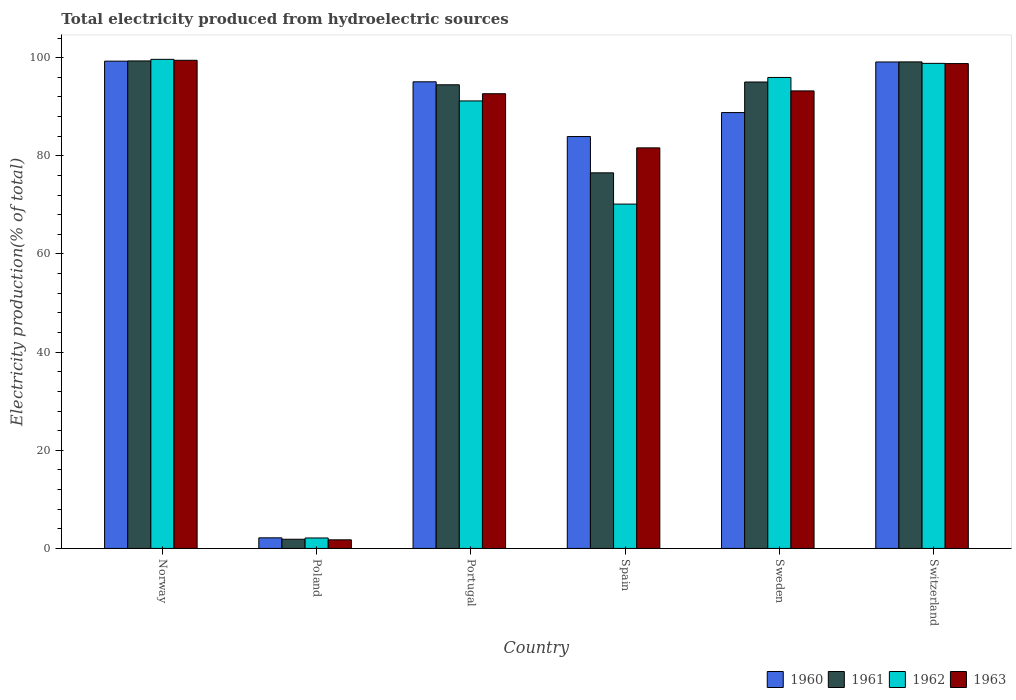How many bars are there on the 4th tick from the left?
Provide a short and direct response. 4. How many bars are there on the 2nd tick from the right?
Make the answer very short. 4. What is the total electricity produced in 1961 in Norway?
Make the answer very short. 99.34. Across all countries, what is the maximum total electricity produced in 1962?
Offer a very short reply. 99.67. Across all countries, what is the minimum total electricity produced in 1962?
Provide a short and direct response. 2.13. What is the total total electricity produced in 1960 in the graph?
Your response must be concise. 468.44. What is the difference between the total electricity produced in 1962 in Norway and that in Poland?
Provide a short and direct response. 97.54. What is the difference between the total electricity produced in 1961 in Sweden and the total electricity produced in 1962 in Poland?
Offer a very short reply. 92.92. What is the average total electricity produced in 1961 per country?
Your answer should be very brief. 77.74. What is the difference between the total electricity produced of/in 1963 and total electricity produced of/in 1962 in Poland?
Keep it short and to the point. -0.38. What is the ratio of the total electricity produced in 1963 in Poland to that in Sweden?
Make the answer very short. 0.02. What is the difference between the highest and the second highest total electricity produced in 1960?
Your answer should be compact. -0.17. What is the difference between the highest and the lowest total electricity produced in 1960?
Your answer should be very brief. 97.14. In how many countries, is the total electricity produced in 1961 greater than the average total electricity produced in 1961 taken over all countries?
Provide a short and direct response. 4. Is the sum of the total electricity produced in 1961 in Norway and Spain greater than the maximum total electricity produced in 1960 across all countries?
Provide a short and direct response. Yes. What does the 1st bar from the right in Portugal represents?
Make the answer very short. 1963. Is it the case that in every country, the sum of the total electricity produced in 1961 and total electricity produced in 1963 is greater than the total electricity produced in 1960?
Your answer should be very brief. Yes. How many bars are there?
Make the answer very short. 24. Are all the bars in the graph horizontal?
Your response must be concise. No. Does the graph contain grids?
Offer a terse response. No. What is the title of the graph?
Keep it short and to the point. Total electricity produced from hydroelectric sources. What is the label or title of the X-axis?
Keep it short and to the point. Country. What is the label or title of the Y-axis?
Your response must be concise. Electricity production(% of total). What is the Electricity production(% of total) of 1960 in Norway?
Ensure brevity in your answer.  99.3. What is the Electricity production(% of total) in 1961 in Norway?
Provide a succinct answer. 99.34. What is the Electricity production(% of total) of 1962 in Norway?
Provide a succinct answer. 99.67. What is the Electricity production(% of total) in 1963 in Norway?
Keep it short and to the point. 99.47. What is the Electricity production(% of total) in 1960 in Poland?
Offer a very short reply. 2.16. What is the Electricity production(% of total) of 1961 in Poland?
Your response must be concise. 1.87. What is the Electricity production(% of total) of 1962 in Poland?
Give a very brief answer. 2.13. What is the Electricity production(% of total) in 1963 in Poland?
Ensure brevity in your answer.  1.75. What is the Electricity production(% of total) in 1960 in Portugal?
Your answer should be compact. 95.09. What is the Electricity production(% of total) of 1961 in Portugal?
Offer a very short reply. 94.48. What is the Electricity production(% of total) in 1962 in Portugal?
Your answer should be very brief. 91.19. What is the Electricity production(% of total) of 1963 in Portugal?
Your answer should be very brief. 92.66. What is the Electricity production(% of total) in 1960 in Spain?
Offer a very short reply. 83.94. What is the Electricity production(% of total) of 1961 in Spain?
Provide a short and direct response. 76.54. What is the Electricity production(% of total) of 1962 in Spain?
Keep it short and to the point. 70.17. What is the Electricity production(% of total) in 1963 in Spain?
Keep it short and to the point. 81.63. What is the Electricity production(% of total) of 1960 in Sweden?
Ensure brevity in your answer.  88.82. What is the Electricity production(% of total) of 1961 in Sweden?
Ensure brevity in your answer.  95.05. What is the Electricity production(% of total) in 1962 in Sweden?
Provide a succinct answer. 95.98. What is the Electricity production(% of total) of 1963 in Sweden?
Offer a very short reply. 93.24. What is the Electricity production(% of total) of 1960 in Switzerland?
Give a very brief answer. 99.13. What is the Electricity production(% of total) of 1961 in Switzerland?
Offer a terse response. 99.15. What is the Electricity production(% of total) in 1962 in Switzerland?
Give a very brief answer. 98.85. What is the Electricity production(% of total) of 1963 in Switzerland?
Offer a very short reply. 98.81. Across all countries, what is the maximum Electricity production(% of total) in 1960?
Make the answer very short. 99.3. Across all countries, what is the maximum Electricity production(% of total) of 1961?
Offer a very short reply. 99.34. Across all countries, what is the maximum Electricity production(% of total) of 1962?
Provide a succinct answer. 99.67. Across all countries, what is the maximum Electricity production(% of total) of 1963?
Give a very brief answer. 99.47. Across all countries, what is the minimum Electricity production(% of total) of 1960?
Provide a succinct answer. 2.16. Across all countries, what is the minimum Electricity production(% of total) of 1961?
Your answer should be very brief. 1.87. Across all countries, what is the minimum Electricity production(% of total) in 1962?
Your answer should be compact. 2.13. Across all countries, what is the minimum Electricity production(% of total) in 1963?
Ensure brevity in your answer.  1.75. What is the total Electricity production(% of total) of 1960 in the graph?
Your answer should be compact. 468.44. What is the total Electricity production(% of total) of 1961 in the graph?
Make the answer very short. 466.43. What is the total Electricity production(% of total) of 1962 in the graph?
Keep it short and to the point. 457.99. What is the total Electricity production(% of total) of 1963 in the graph?
Offer a terse response. 467.56. What is the difference between the Electricity production(% of total) of 1960 in Norway and that in Poland?
Your answer should be very brief. 97.14. What is the difference between the Electricity production(% of total) of 1961 in Norway and that in Poland?
Make the answer very short. 97.47. What is the difference between the Electricity production(% of total) of 1962 in Norway and that in Poland?
Offer a very short reply. 97.54. What is the difference between the Electricity production(% of total) in 1963 in Norway and that in Poland?
Make the answer very short. 97.72. What is the difference between the Electricity production(% of total) of 1960 in Norway and that in Portugal?
Your answer should be compact. 4.21. What is the difference between the Electricity production(% of total) of 1961 in Norway and that in Portugal?
Provide a short and direct response. 4.86. What is the difference between the Electricity production(% of total) of 1962 in Norway and that in Portugal?
Your response must be concise. 8.48. What is the difference between the Electricity production(% of total) in 1963 in Norway and that in Portugal?
Offer a terse response. 6.81. What is the difference between the Electricity production(% of total) in 1960 in Norway and that in Spain?
Provide a succinct answer. 15.36. What is the difference between the Electricity production(% of total) of 1961 in Norway and that in Spain?
Provide a succinct answer. 22.8. What is the difference between the Electricity production(% of total) in 1962 in Norway and that in Spain?
Your answer should be compact. 29.5. What is the difference between the Electricity production(% of total) in 1963 in Norway and that in Spain?
Give a very brief answer. 17.85. What is the difference between the Electricity production(% of total) in 1960 in Norway and that in Sweden?
Give a very brief answer. 10.48. What is the difference between the Electricity production(% of total) of 1961 in Norway and that in Sweden?
Your response must be concise. 4.29. What is the difference between the Electricity production(% of total) of 1962 in Norway and that in Sweden?
Provide a short and direct response. 3.69. What is the difference between the Electricity production(% of total) in 1963 in Norway and that in Sweden?
Ensure brevity in your answer.  6.24. What is the difference between the Electricity production(% of total) of 1960 in Norway and that in Switzerland?
Your response must be concise. 0.17. What is the difference between the Electricity production(% of total) in 1961 in Norway and that in Switzerland?
Offer a very short reply. 0.2. What is the difference between the Electricity production(% of total) in 1962 in Norway and that in Switzerland?
Keep it short and to the point. 0.82. What is the difference between the Electricity production(% of total) of 1963 in Norway and that in Switzerland?
Your answer should be compact. 0.67. What is the difference between the Electricity production(% of total) in 1960 in Poland and that in Portugal?
Ensure brevity in your answer.  -92.93. What is the difference between the Electricity production(% of total) of 1961 in Poland and that in Portugal?
Provide a short and direct response. -92.61. What is the difference between the Electricity production(% of total) in 1962 in Poland and that in Portugal?
Provide a succinct answer. -89.06. What is the difference between the Electricity production(% of total) of 1963 in Poland and that in Portugal?
Give a very brief answer. -90.91. What is the difference between the Electricity production(% of total) of 1960 in Poland and that in Spain?
Provide a succinct answer. -81.78. What is the difference between the Electricity production(% of total) of 1961 in Poland and that in Spain?
Offer a very short reply. -74.67. What is the difference between the Electricity production(% of total) in 1962 in Poland and that in Spain?
Your response must be concise. -68.04. What is the difference between the Electricity production(% of total) in 1963 in Poland and that in Spain?
Offer a terse response. -79.88. What is the difference between the Electricity production(% of total) of 1960 in Poland and that in Sweden?
Provide a succinct answer. -86.66. What is the difference between the Electricity production(% of total) of 1961 in Poland and that in Sweden?
Your answer should be compact. -93.17. What is the difference between the Electricity production(% of total) in 1962 in Poland and that in Sweden?
Offer a terse response. -93.84. What is the difference between the Electricity production(% of total) of 1963 in Poland and that in Sweden?
Give a very brief answer. -91.48. What is the difference between the Electricity production(% of total) in 1960 in Poland and that in Switzerland?
Keep it short and to the point. -96.97. What is the difference between the Electricity production(% of total) in 1961 in Poland and that in Switzerland?
Offer a terse response. -97.27. What is the difference between the Electricity production(% of total) of 1962 in Poland and that in Switzerland?
Make the answer very short. -96.71. What is the difference between the Electricity production(% of total) in 1963 in Poland and that in Switzerland?
Provide a short and direct response. -97.06. What is the difference between the Electricity production(% of total) of 1960 in Portugal and that in Spain?
Offer a terse response. 11.15. What is the difference between the Electricity production(% of total) in 1961 in Portugal and that in Spain?
Provide a short and direct response. 17.94. What is the difference between the Electricity production(% of total) of 1962 in Portugal and that in Spain?
Make the answer very short. 21.02. What is the difference between the Electricity production(% of total) in 1963 in Portugal and that in Spain?
Make the answer very short. 11.03. What is the difference between the Electricity production(% of total) of 1960 in Portugal and that in Sweden?
Offer a terse response. 6.27. What is the difference between the Electricity production(% of total) in 1961 in Portugal and that in Sweden?
Offer a terse response. -0.57. What is the difference between the Electricity production(% of total) in 1962 in Portugal and that in Sweden?
Give a very brief answer. -4.78. What is the difference between the Electricity production(% of total) of 1963 in Portugal and that in Sweden?
Keep it short and to the point. -0.58. What is the difference between the Electricity production(% of total) in 1960 in Portugal and that in Switzerland?
Make the answer very short. -4.04. What is the difference between the Electricity production(% of total) in 1961 in Portugal and that in Switzerland?
Offer a very short reply. -4.67. What is the difference between the Electricity production(% of total) in 1962 in Portugal and that in Switzerland?
Ensure brevity in your answer.  -7.65. What is the difference between the Electricity production(% of total) of 1963 in Portugal and that in Switzerland?
Make the answer very short. -6.15. What is the difference between the Electricity production(% of total) in 1960 in Spain and that in Sweden?
Provide a succinct answer. -4.88. What is the difference between the Electricity production(% of total) in 1961 in Spain and that in Sweden?
Offer a terse response. -18.51. What is the difference between the Electricity production(% of total) of 1962 in Spain and that in Sweden?
Ensure brevity in your answer.  -25.8. What is the difference between the Electricity production(% of total) in 1963 in Spain and that in Sweden?
Your response must be concise. -11.61. What is the difference between the Electricity production(% of total) in 1960 in Spain and that in Switzerland?
Offer a very short reply. -15.19. What is the difference between the Electricity production(% of total) of 1961 in Spain and that in Switzerland?
Your answer should be compact. -22.61. What is the difference between the Electricity production(% of total) of 1962 in Spain and that in Switzerland?
Ensure brevity in your answer.  -28.67. What is the difference between the Electricity production(% of total) of 1963 in Spain and that in Switzerland?
Offer a very short reply. -17.18. What is the difference between the Electricity production(% of total) of 1960 in Sweden and that in Switzerland?
Give a very brief answer. -10.31. What is the difference between the Electricity production(% of total) in 1961 in Sweden and that in Switzerland?
Offer a very short reply. -4.1. What is the difference between the Electricity production(% of total) of 1962 in Sweden and that in Switzerland?
Your response must be concise. -2.87. What is the difference between the Electricity production(% of total) of 1963 in Sweden and that in Switzerland?
Your response must be concise. -5.57. What is the difference between the Electricity production(% of total) in 1960 in Norway and the Electricity production(% of total) in 1961 in Poland?
Offer a very short reply. 97.43. What is the difference between the Electricity production(% of total) in 1960 in Norway and the Electricity production(% of total) in 1962 in Poland?
Ensure brevity in your answer.  97.17. What is the difference between the Electricity production(% of total) of 1960 in Norway and the Electricity production(% of total) of 1963 in Poland?
Provide a short and direct response. 97.55. What is the difference between the Electricity production(% of total) in 1961 in Norway and the Electricity production(% of total) in 1962 in Poland?
Your response must be concise. 97.21. What is the difference between the Electricity production(% of total) in 1961 in Norway and the Electricity production(% of total) in 1963 in Poland?
Provide a short and direct response. 97.59. What is the difference between the Electricity production(% of total) of 1962 in Norway and the Electricity production(% of total) of 1963 in Poland?
Provide a short and direct response. 97.92. What is the difference between the Electricity production(% of total) of 1960 in Norway and the Electricity production(% of total) of 1961 in Portugal?
Provide a succinct answer. 4.82. What is the difference between the Electricity production(% of total) in 1960 in Norway and the Electricity production(% of total) in 1962 in Portugal?
Offer a terse response. 8.11. What is the difference between the Electricity production(% of total) of 1960 in Norway and the Electricity production(% of total) of 1963 in Portugal?
Give a very brief answer. 6.64. What is the difference between the Electricity production(% of total) of 1961 in Norway and the Electricity production(% of total) of 1962 in Portugal?
Offer a very short reply. 8.15. What is the difference between the Electricity production(% of total) of 1961 in Norway and the Electricity production(% of total) of 1963 in Portugal?
Ensure brevity in your answer.  6.68. What is the difference between the Electricity production(% of total) in 1962 in Norway and the Electricity production(% of total) in 1963 in Portugal?
Your answer should be compact. 7.01. What is the difference between the Electricity production(% of total) in 1960 in Norway and the Electricity production(% of total) in 1961 in Spain?
Ensure brevity in your answer.  22.76. What is the difference between the Electricity production(% of total) of 1960 in Norway and the Electricity production(% of total) of 1962 in Spain?
Keep it short and to the point. 29.13. What is the difference between the Electricity production(% of total) of 1960 in Norway and the Electricity production(% of total) of 1963 in Spain?
Offer a terse response. 17.67. What is the difference between the Electricity production(% of total) of 1961 in Norway and the Electricity production(% of total) of 1962 in Spain?
Make the answer very short. 29.17. What is the difference between the Electricity production(% of total) of 1961 in Norway and the Electricity production(% of total) of 1963 in Spain?
Give a very brief answer. 17.72. What is the difference between the Electricity production(% of total) of 1962 in Norway and the Electricity production(% of total) of 1963 in Spain?
Ensure brevity in your answer.  18.04. What is the difference between the Electricity production(% of total) of 1960 in Norway and the Electricity production(% of total) of 1961 in Sweden?
Your answer should be very brief. 4.25. What is the difference between the Electricity production(% of total) in 1960 in Norway and the Electricity production(% of total) in 1962 in Sweden?
Provide a succinct answer. 3.33. What is the difference between the Electricity production(% of total) in 1960 in Norway and the Electricity production(% of total) in 1963 in Sweden?
Your response must be concise. 6.06. What is the difference between the Electricity production(% of total) of 1961 in Norway and the Electricity production(% of total) of 1962 in Sweden?
Keep it short and to the point. 3.37. What is the difference between the Electricity production(% of total) in 1961 in Norway and the Electricity production(% of total) in 1963 in Sweden?
Provide a succinct answer. 6.11. What is the difference between the Electricity production(% of total) of 1962 in Norway and the Electricity production(% of total) of 1963 in Sweden?
Your response must be concise. 6.43. What is the difference between the Electricity production(% of total) of 1960 in Norway and the Electricity production(% of total) of 1961 in Switzerland?
Make the answer very short. 0.15. What is the difference between the Electricity production(% of total) of 1960 in Norway and the Electricity production(% of total) of 1962 in Switzerland?
Your answer should be very brief. 0.45. What is the difference between the Electricity production(% of total) in 1960 in Norway and the Electricity production(% of total) in 1963 in Switzerland?
Keep it short and to the point. 0.49. What is the difference between the Electricity production(% of total) in 1961 in Norway and the Electricity production(% of total) in 1962 in Switzerland?
Make the answer very short. 0.5. What is the difference between the Electricity production(% of total) of 1961 in Norway and the Electricity production(% of total) of 1963 in Switzerland?
Ensure brevity in your answer.  0.54. What is the difference between the Electricity production(% of total) in 1962 in Norway and the Electricity production(% of total) in 1963 in Switzerland?
Give a very brief answer. 0.86. What is the difference between the Electricity production(% of total) of 1960 in Poland and the Electricity production(% of total) of 1961 in Portugal?
Your answer should be compact. -92.32. What is the difference between the Electricity production(% of total) in 1960 in Poland and the Electricity production(% of total) in 1962 in Portugal?
Your answer should be very brief. -89.03. What is the difference between the Electricity production(% of total) of 1960 in Poland and the Electricity production(% of total) of 1963 in Portugal?
Give a very brief answer. -90.5. What is the difference between the Electricity production(% of total) of 1961 in Poland and the Electricity production(% of total) of 1962 in Portugal?
Provide a succinct answer. -89.32. What is the difference between the Electricity production(% of total) of 1961 in Poland and the Electricity production(% of total) of 1963 in Portugal?
Give a very brief answer. -90.79. What is the difference between the Electricity production(% of total) in 1962 in Poland and the Electricity production(% of total) in 1963 in Portugal?
Offer a terse response. -90.53. What is the difference between the Electricity production(% of total) of 1960 in Poland and the Electricity production(% of total) of 1961 in Spain?
Your response must be concise. -74.38. What is the difference between the Electricity production(% of total) in 1960 in Poland and the Electricity production(% of total) in 1962 in Spain?
Offer a very short reply. -68.01. What is the difference between the Electricity production(% of total) of 1960 in Poland and the Electricity production(% of total) of 1963 in Spain?
Give a very brief answer. -79.47. What is the difference between the Electricity production(% of total) of 1961 in Poland and the Electricity production(% of total) of 1962 in Spain?
Your answer should be compact. -68.3. What is the difference between the Electricity production(% of total) in 1961 in Poland and the Electricity production(% of total) in 1963 in Spain?
Keep it short and to the point. -79.75. What is the difference between the Electricity production(% of total) in 1962 in Poland and the Electricity production(% of total) in 1963 in Spain?
Give a very brief answer. -79.5. What is the difference between the Electricity production(% of total) of 1960 in Poland and the Electricity production(% of total) of 1961 in Sweden?
Offer a terse response. -92.89. What is the difference between the Electricity production(% of total) of 1960 in Poland and the Electricity production(% of total) of 1962 in Sweden?
Provide a succinct answer. -93.82. What is the difference between the Electricity production(% of total) in 1960 in Poland and the Electricity production(% of total) in 1963 in Sweden?
Your response must be concise. -91.08. What is the difference between the Electricity production(% of total) in 1961 in Poland and the Electricity production(% of total) in 1962 in Sweden?
Make the answer very short. -94.1. What is the difference between the Electricity production(% of total) in 1961 in Poland and the Electricity production(% of total) in 1963 in Sweden?
Your answer should be very brief. -91.36. What is the difference between the Electricity production(% of total) of 1962 in Poland and the Electricity production(% of total) of 1963 in Sweden?
Provide a short and direct response. -91.1. What is the difference between the Electricity production(% of total) of 1960 in Poland and the Electricity production(% of total) of 1961 in Switzerland?
Your response must be concise. -96.99. What is the difference between the Electricity production(% of total) of 1960 in Poland and the Electricity production(% of total) of 1962 in Switzerland?
Keep it short and to the point. -96.69. What is the difference between the Electricity production(% of total) of 1960 in Poland and the Electricity production(% of total) of 1963 in Switzerland?
Provide a succinct answer. -96.65. What is the difference between the Electricity production(% of total) of 1961 in Poland and the Electricity production(% of total) of 1962 in Switzerland?
Offer a terse response. -96.97. What is the difference between the Electricity production(% of total) in 1961 in Poland and the Electricity production(% of total) in 1963 in Switzerland?
Offer a very short reply. -96.93. What is the difference between the Electricity production(% of total) of 1962 in Poland and the Electricity production(% of total) of 1963 in Switzerland?
Your answer should be compact. -96.67. What is the difference between the Electricity production(% of total) in 1960 in Portugal and the Electricity production(% of total) in 1961 in Spain?
Your response must be concise. 18.55. What is the difference between the Electricity production(% of total) of 1960 in Portugal and the Electricity production(% of total) of 1962 in Spain?
Offer a terse response. 24.92. What is the difference between the Electricity production(% of total) of 1960 in Portugal and the Electricity production(% of total) of 1963 in Spain?
Offer a very short reply. 13.46. What is the difference between the Electricity production(% of total) of 1961 in Portugal and the Electricity production(% of total) of 1962 in Spain?
Provide a succinct answer. 24.31. What is the difference between the Electricity production(% of total) in 1961 in Portugal and the Electricity production(% of total) in 1963 in Spain?
Provide a succinct answer. 12.85. What is the difference between the Electricity production(% of total) in 1962 in Portugal and the Electricity production(% of total) in 1963 in Spain?
Give a very brief answer. 9.57. What is the difference between the Electricity production(% of total) of 1960 in Portugal and the Electricity production(% of total) of 1961 in Sweden?
Ensure brevity in your answer.  0.04. What is the difference between the Electricity production(% of total) of 1960 in Portugal and the Electricity production(% of total) of 1962 in Sweden?
Offer a terse response. -0.89. What is the difference between the Electricity production(% of total) in 1960 in Portugal and the Electricity production(% of total) in 1963 in Sweden?
Your answer should be very brief. 1.85. What is the difference between the Electricity production(% of total) of 1961 in Portugal and the Electricity production(% of total) of 1962 in Sweden?
Give a very brief answer. -1.49. What is the difference between the Electricity production(% of total) of 1961 in Portugal and the Electricity production(% of total) of 1963 in Sweden?
Offer a very short reply. 1.24. What is the difference between the Electricity production(% of total) of 1962 in Portugal and the Electricity production(% of total) of 1963 in Sweden?
Your answer should be very brief. -2.04. What is the difference between the Electricity production(% of total) of 1960 in Portugal and the Electricity production(% of total) of 1961 in Switzerland?
Offer a terse response. -4.06. What is the difference between the Electricity production(% of total) of 1960 in Portugal and the Electricity production(% of total) of 1962 in Switzerland?
Make the answer very short. -3.76. What is the difference between the Electricity production(% of total) in 1960 in Portugal and the Electricity production(% of total) in 1963 in Switzerland?
Offer a very short reply. -3.72. What is the difference between the Electricity production(% of total) in 1961 in Portugal and the Electricity production(% of total) in 1962 in Switzerland?
Your answer should be compact. -4.37. What is the difference between the Electricity production(% of total) of 1961 in Portugal and the Electricity production(% of total) of 1963 in Switzerland?
Your answer should be compact. -4.33. What is the difference between the Electricity production(% of total) of 1962 in Portugal and the Electricity production(% of total) of 1963 in Switzerland?
Provide a succinct answer. -7.61. What is the difference between the Electricity production(% of total) in 1960 in Spain and the Electricity production(% of total) in 1961 in Sweden?
Your response must be concise. -11.11. What is the difference between the Electricity production(% of total) of 1960 in Spain and the Electricity production(% of total) of 1962 in Sweden?
Ensure brevity in your answer.  -12.04. What is the difference between the Electricity production(% of total) in 1960 in Spain and the Electricity production(% of total) in 1963 in Sweden?
Your answer should be compact. -9.3. What is the difference between the Electricity production(% of total) in 1961 in Spain and the Electricity production(% of total) in 1962 in Sweden?
Provide a short and direct response. -19.44. What is the difference between the Electricity production(% of total) of 1961 in Spain and the Electricity production(% of total) of 1963 in Sweden?
Your answer should be very brief. -16.7. What is the difference between the Electricity production(% of total) of 1962 in Spain and the Electricity production(% of total) of 1963 in Sweden?
Make the answer very short. -23.06. What is the difference between the Electricity production(% of total) in 1960 in Spain and the Electricity production(% of total) in 1961 in Switzerland?
Offer a terse response. -15.21. What is the difference between the Electricity production(% of total) in 1960 in Spain and the Electricity production(% of total) in 1962 in Switzerland?
Offer a terse response. -14.91. What is the difference between the Electricity production(% of total) of 1960 in Spain and the Electricity production(% of total) of 1963 in Switzerland?
Your response must be concise. -14.87. What is the difference between the Electricity production(% of total) in 1961 in Spain and the Electricity production(% of total) in 1962 in Switzerland?
Offer a very short reply. -22.31. What is the difference between the Electricity production(% of total) in 1961 in Spain and the Electricity production(% of total) in 1963 in Switzerland?
Offer a terse response. -22.27. What is the difference between the Electricity production(% of total) in 1962 in Spain and the Electricity production(% of total) in 1963 in Switzerland?
Make the answer very short. -28.63. What is the difference between the Electricity production(% of total) in 1960 in Sweden and the Electricity production(% of total) in 1961 in Switzerland?
Your answer should be compact. -10.33. What is the difference between the Electricity production(% of total) of 1960 in Sweden and the Electricity production(% of total) of 1962 in Switzerland?
Make the answer very short. -10.03. What is the difference between the Electricity production(% of total) of 1960 in Sweden and the Electricity production(% of total) of 1963 in Switzerland?
Make the answer very short. -9.99. What is the difference between the Electricity production(% of total) in 1961 in Sweden and the Electricity production(% of total) in 1962 in Switzerland?
Offer a terse response. -3.8. What is the difference between the Electricity production(% of total) of 1961 in Sweden and the Electricity production(% of total) of 1963 in Switzerland?
Offer a very short reply. -3.76. What is the difference between the Electricity production(% of total) of 1962 in Sweden and the Electricity production(% of total) of 1963 in Switzerland?
Give a very brief answer. -2.83. What is the average Electricity production(% of total) in 1960 per country?
Provide a succinct answer. 78.07. What is the average Electricity production(% of total) of 1961 per country?
Make the answer very short. 77.74. What is the average Electricity production(% of total) of 1962 per country?
Your answer should be very brief. 76.33. What is the average Electricity production(% of total) of 1963 per country?
Provide a short and direct response. 77.93. What is the difference between the Electricity production(% of total) of 1960 and Electricity production(% of total) of 1961 in Norway?
Ensure brevity in your answer.  -0.04. What is the difference between the Electricity production(% of total) in 1960 and Electricity production(% of total) in 1962 in Norway?
Your answer should be compact. -0.37. What is the difference between the Electricity production(% of total) in 1960 and Electricity production(% of total) in 1963 in Norway?
Your answer should be compact. -0.17. What is the difference between the Electricity production(% of total) of 1961 and Electricity production(% of total) of 1962 in Norway?
Provide a succinct answer. -0.33. What is the difference between the Electricity production(% of total) in 1961 and Electricity production(% of total) in 1963 in Norway?
Your response must be concise. -0.13. What is the difference between the Electricity production(% of total) of 1962 and Electricity production(% of total) of 1963 in Norway?
Offer a very short reply. 0.19. What is the difference between the Electricity production(% of total) in 1960 and Electricity production(% of total) in 1961 in Poland?
Provide a succinct answer. 0.28. What is the difference between the Electricity production(% of total) in 1960 and Electricity production(% of total) in 1962 in Poland?
Give a very brief answer. 0.03. What is the difference between the Electricity production(% of total) in 1960 and Electricity production(% of total) in 1963 in Poland?
Ensure brevity in your answer.  0.41. What is the difference between the Electricity production(% of total) in 1961 and Electricity production(% of total) in 1962 in Poland?
Offer a terse response. -0.26. What is the difference between the Electricity production(% of total) of 1961 and Electricity production(% of total) of 1963 in Poland?
Give a very brief answer. 0.12. What is the difference between the Electricity production(% of total) in 1962 and Electricity production(% of total) in 1963 in Poland?
Ensure brevity in your answer.  0.38. What is the difference between the Electricity production(% of total) of 1960 and Electricity production(% of total) of 1961 in Portugal?
Make the answer very short. 0.61. What is the difference between the Electricity production(% of total) of 1960 and Electricity production(% of total) of 1962 in Portugal?
Provide a short and direct response. 3.9. What is the difference between the Electricity production(% of total) of 1960 and Electricity production(% of total) of 1963 in Portugal?
Your answer should be very brief. 2.43. What is the difference between the Electricity production(% of total) of 1961 and Electricity production(% of total) of 1962 in Portugal?
Offer a very short reply. 3.29. What is the difference between the Electricity production(% of total) in 1961 and Electricity production(% of total) in 1963 in Portugal?
Offer a very short reply. 1.82. What is the difference between the Electricity production(% of total) in 1962 and Electricity production(% of total) in 1963 in Portugal?
Offer a very short reply. -1.47. What is the difference between the Electricity production(% of total) of 1960 and Electricity production(% of total) of 1961 in Spain?
Your response must be concise. 7.4. What is the difference between the Electricity production(% of total) of 1960 and Electricity production(% of total) of 1962 in Spain?
Ensure brevity in your answer.  13.76. What is the difference between the Electricity production(% of total) in 1960 and Electricity production(% of total) in 1963 in Spain?
Offer a very short reply. 2.31. What is the difference between the Electricity production(% of total) of 1961 and Electricity production(% of total) of 1962 in Spain?
Offer a very short reply. 6.37. What is the difference between the Electricity production(% of total) in 1961 and Electricity production(% of total) in 1963 in Spain?
Ensure brevity in your answer.  -5.09. What is the difference between the Electricity production(% of total) in 1962 and Electricity production(% of total) in 1963 in Spain?
Provide a short and direct response. -11.45. What is the difference between the Electricity production(% of total) of 1960 and Electricity production(% of total) of 1961 in Sweden?
Make the answer very short. -6.23. What is the difference between the Electricity production(% of total) in 1960 and Electricity production(% of total) in 1962 in Sweden?
Give a very brief answer. -7.16. What is the difference between the Electricity production(% of total) in 1960 and Electricity production(% of total) in 1963 in Sweden?
Your answer should be compact. -4.42. What is the difference between the Electricity production(% of total) of 1961 and Electricity production(% of total) of 1962 in Sweden?
Offer a terse response. -0.93. What is the difference between the Electricity production(% of total) in 1961 and Electricity production(% of total) in 1963 in Sweden?
Offer a terse response. 1.81. What is the difference between the Electricity production(% of total) of 1962 and Electricity production(% of total) of 1963 in Sweden?
Keep it short and to the point. 2.74. What is the difference between the Electricity production(% of total) of 1960 and Electricity production(% of total) of 1961 in Switzerland?
Provide a short and direct response. -0.02. What is the difference between the Electricity production(% of total) in 1960 and Electricity production(% of total) in 1962 in Switzerland?
Offer a terse response. 0.28. What is the difference between the Electricity production(% of total) in 1960 and Electricity production(% of total) in 1963 in Switzerland?
Your answer should be compact. 0.32. What is the difference between the Electricity production(% of total) of 1961 and Electricity production(% of total) of 1962 in Switzerland?
Ensure brevity in your answer.  0.3. What is the difference between the Electricity production(% of total) of 1961 and Electricity production(% of total) of 1963 in Switzerland?
Your response must be concise. 0.34. What is the difference between the Electricity production(% of total) in 1962 and Electricity production(% of total) in 1963 in Switzerland?
Provide a succinct answer. 0.04. What is the ratio of the Electricity production(% of total) of 1960 in Norway to that in Poland?
Ensure brevity in your answer.  46.01. What is the ratio of the Electricity production(% of total) in 1961 in Norway to that in Poland?
Ensure brevity in your answer.  53.03. What is the ratio of the Electricity production(% of total) of 1962 in Norway to that in Poland?
Provide a succinct answer. 46.75. What is the ratio of the Electricity production(% of total) of 1963 in Norway to that in Poland?
Make the answer very short. 56.8. What is the ratio of the Electricity production(% of total) in 1960 in Norway to that in Portugal?
Offer a terse response. 1.04. What is the ratio of the Electricity production(% of total) in 1961 in Norway to that in Portugal?
Make the answer very short. 1.05. What is the ratio of the Electricity production(% of total) of 1962 in Norway to that in Portugal?
Your response must be concise. 1.09. What is the ratio of the Electricity production(% of total) of 1963 in Norway to that in Portugal?
Ensure brevity in your answer.  1.07. What is the ratio of the Electricity production(% of total) in 1960 in Norway to that in Spain?
Your answer should be very brief. 1.18. What is the ratio of the Electricity production(% of total) of 1961 in Norway to that in Spain?
Your answer should be compact. 1.3. What is the ratio of the Electricity production(% of total) in 1962 in Norway to that in Spain?
Your answer should be very brief. 1.42. What is the ratio of the Electricity production(% of total) in 1963 in Norway to that in Spain?
Offer a very short reply. 1.22. What is the ratio of the Electricity production(% of total) in 1960 in Norway to that in Sweden?
Give a very brief answer. 1.12. What is the ratio of the Electricity production(% of total) in 1961 in Norway to that in Sweden?
Provide a succinct answer. 1.05. What is the ratio of the Electricity production(% of total) of 1963 in Norway to that in Sweden?
Keep it short and to the point. 1.07. What is the ratio of the Electricity production(% of total) of 1960 in Norway to that in Switzerland?
Your answer should be compact. 1. What is the ratio of the Electricity production(% of total) of 1962 in Norway to that in Switzerland?
Your answer should be compact. 1.01. What is the ratio of the Electricity production(% of total) of 1963 in Norway to that in Switzerland?
Your answer should be very brief. 1.01. What is the ratio of the Electricity production(% of total) in 1960 in Poland to that in Portugal?
Ensure brevity in your answer.  0.02. What is the ratio of the Electricity production(% of total) in 1961 in Poland to that in Portugal?
Offer a very short reply. 0.02. What is the ratio of the Electricity production(% of total) in 1962 in Poland to that in Portugal?
Your answer should be compact. 0.02. What is the ratio of the Electricity production(% of total) in 1963 in Poland to that in Portugal?
Your answer should be very brief. 0.02. What is the ratio of the Electricity production(% of total) of 1960 in Poland to that in Spain?
Offer a very short reply. 0.03. What is the ratio of the Electricity production(% of total) of 1961 in Poland to that in Spain?
Offer a terse response. 0.02. What is the ratio of the Electricity production(% of total) in 1962 in Poland to that in Spain?
Make the answer very short. 0.03. What is the ratio of the Electricity production(% of total) of 1963 in Poland to that in Spain?
Make the answer very short. 0.02. What is the ratio of the Electricity production(% of total) of 1960 in Poland to that in Sweden?
Make the answer very short. 0.02. What is the ratio of the Electricity production(% of total) in 1961 in Poland to that in Sweden?
Provide a succinct answer. 0.02. What is the ratio of the Electricity production(% of total) of 1962 in Poland to that in Sweden?
Your answer should be compact. 0.02. What is the ratio of the Electricity production(% of total) of 1963 in Poland to that in Sweden?
Offer a very short reply. 0.02. What is the ratio of the Electricity production(% of total) in 1960 in Poland to that in Switzerland?
Make the answer very short. 0.02. What is the ratio of the Electricity production(% of total) of 1961 in Poland to that in Switzerland?
Provide a short and direct response. 0.02. What is the ratio of the Electricity production(% of total) in 1962 in Poland to that in Switzerland?
Offer a terse response. 0.02. What is the ratio of the Electricity production(% of total) in 1963 in Poland to that in Switzerland?
Offer a terse response. 0.02. What is the ratio of the Electricity production(% of total) of 1960 in Portugal to that in Spain?
Make the answer very short. 1.13. What is the ratio of the Electricity production(% of total) of 1961 in Portugal to that in Spain?
Keep it short and to the point. 1.23. What is the ratio of the Electricity production(% of total) in 1962 in Portugal to that in Spain?
Your answer should be compact. 1.3. What is the ratio of the Electricity production(% of total) of 1963 in Portugal to that in Spain?
Offer a very short reply. 1.14. What is the ratio of the Electricity production(% of total) of 1960 in Portugal to that in Sweden?
Offer a terse response. 1.07. What is the ratio of the Electricity production(% of total) in 1962 in Portugal to that in Sweden?
Give a very brief answer. 0.95. What is the ratio of the Electricity production(% of total) in 1963 in Portugal to that in Sweden?
Your answer should be compact. 0.99. What is the ratio of the Electricity production(% of total) in 1960 in Portugal to that in Switzerland?
Provide a succinct answer. 0.96. What is the ratio of the Electricity production(% of total) in 1961 in Portugal to that in Switzerland?
Keep it short and to the point. 0.95. What is the ratio of the Electricity production(% of total) in 1962 in Portugal to that in Switzerland?
Keep it short and to the point. 0.92. What is the ratio of the Electricity production(% of total) of 1963 in Portugal to that in Switzerland?
Your answer should be compact. 0.94. What is the ratio of the Electricity production(% of total) of 1960 in Spain to that in Sweden?
Your answer should be compact. 0.94. What is the ratio of the Electricity production(% of total) in 1961 in Spain to that in Sweden?
Your answer should be compact. 0.81. What is the ratio of the Electricity production(% of total) in 1962 in Spain to that in Sweden?
Ensure brevity in your answer.  0.73. What is the ratio of the Electricity production(% of total) of 1963 in Spain to that in Sweden?
Provide a short and direct response. 0.88. What is the ratio of the Electricity production(% of total) of 1960 in Spain to that in Switzerland?
Ensure brevity in your answer.  0.85. What is the ratio of the Electricity production(% of total) in 1961 in Spain to that in Switzerland?
Offer a terse response. 0.77. What is the ratio of the Electricity production(% of total) of 1962 in Spain to that in Switzerland?
Ensure brevity in your answer.  0.71. What is the ratio of the Electricity production(% of total) of 1963 in Spain to that in Switzerland?
Offer a terse response. 0.83. What is the ratio of the Electricity production(% of total) in 1960 in Sweden to that in Switzerland?
Keep it short and to the point. 0.9. What is the ratio of the Electricity production(% of total) in 1961 in Sweden to that in Switzerland?
Offer a terse response. 0.96. What is the ratio of the Electricity production(% of total) of 1962 in Sweden to that in Switzerland?
Offer a very short reply. 0.97. What is the ratio of the Electricity production(% of total) of 1963 in Sweden to that in Switzerland?
Provide a short and direct response. 0.94. What is the difference between the highest and the second highest Electricity production(% of total) in 1960?
Your response must be concise. 0.17. What is the difference between the highest and the second highest Electricity production(% of total) in 1961?
Your response must be concise. 0.2. What is the difference between the highest and the second highest Electricity production(% of total) in 1962?
Your response must be concise. 0.82. What is the difference between the highest and the second highest Electricity production(% of total) of 1963?
Keep it short and to the point. 0.67. What is the difference between the highest and the lowest Electricity production(% of total) of 1960?
Give a very brief answer. 97.14. What is the difference between the highest and the lowest Electricity production(% of total) in 1961?
Give a very brief answer. 97.47. What is the difference between the highest and the lowest Electricity production(% of total) in 1962?
Ensure brevity in your answer.  97.54. What is the difference between the highest and the lowest Electricity production(% of total) of 1963?
Make the answer very short. 97.72. 